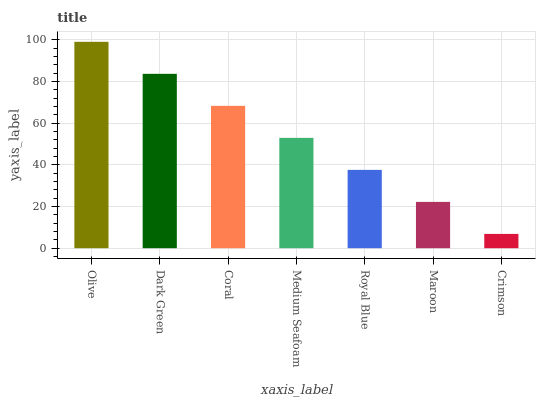Is Crimson the minimum?
Answer yes or no. Yes. Is Olive the maximum?
Answer yes or no. Yes. Is Dark Green the minimum?
Answer yes or no. No. Is Dark Green the maximum?
Answer yes or no. No. Is Olive greater than Dark Green?
Answer yes or no. Yes. Is Dark Green less than Olive?
Answer yes or no. Yes. Is Dark Green greater than Olive?
Answer yes or no. No. Is Olive less than Dark Green?
Answer yes or no. No. Is Medium Seafoam the high median?
Answer yes or no. Yes. Is Medium Seafoam the low median?
Answer yes or no. Yes. Is Maroon the high median?
Answer yes or no. No. Is Dark Green the low median?
Answer yes or no. No. 